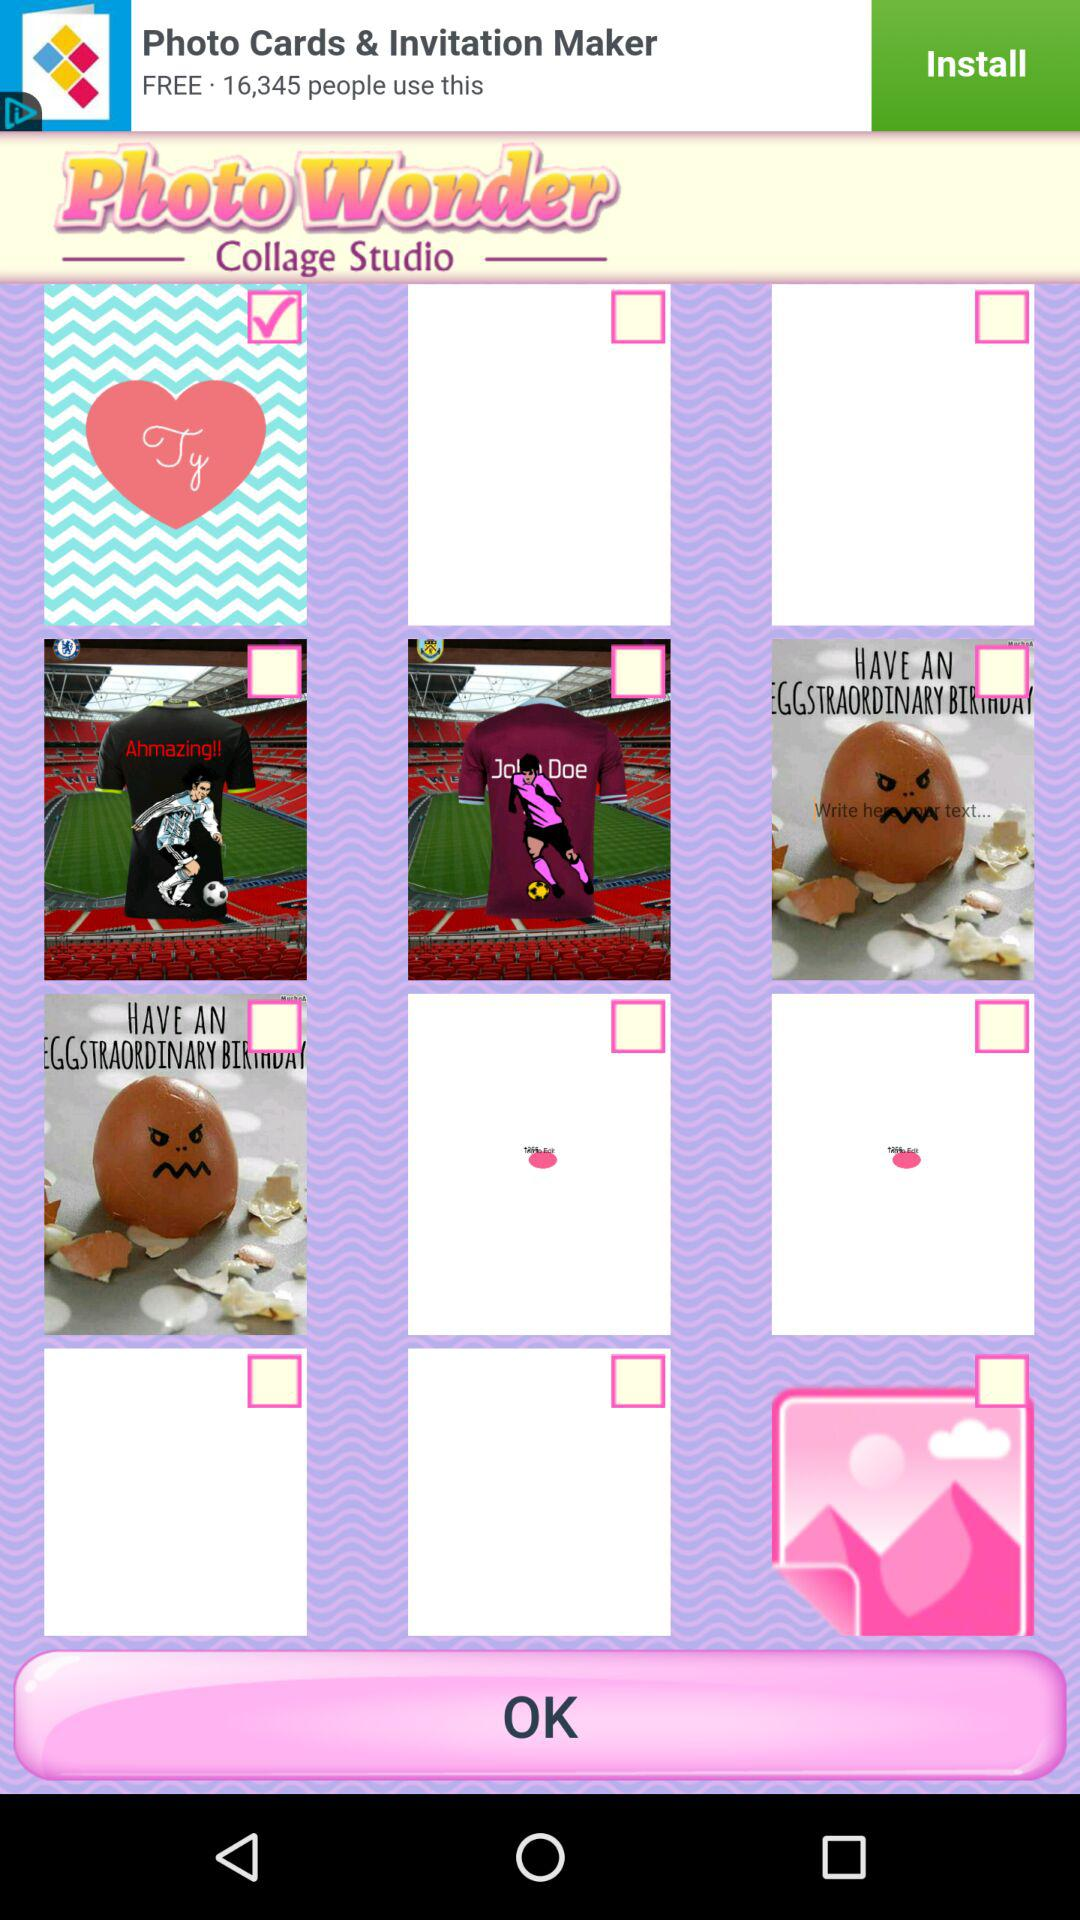What is the application name? The application name is "Photo Wonder Collage Studio". 